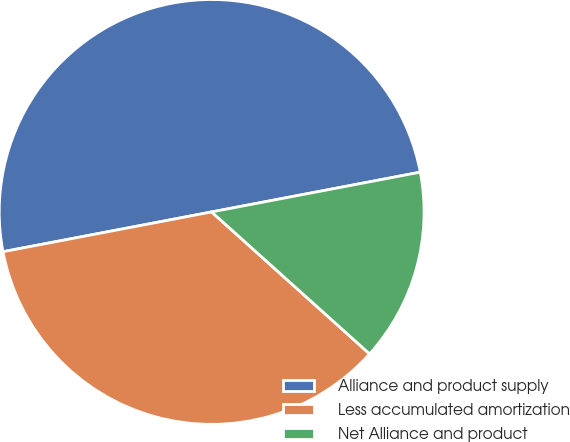<chart> <loc_0><loc_0><loc_500><loc_500><pie_chart><fcel>Alliance and product supply<fcel>Less accumulated amortization<fcel>Net Alliance and product<nl><fcel>50.0%<fcel>35.35%<fcel>14.65%<nl></chart> 